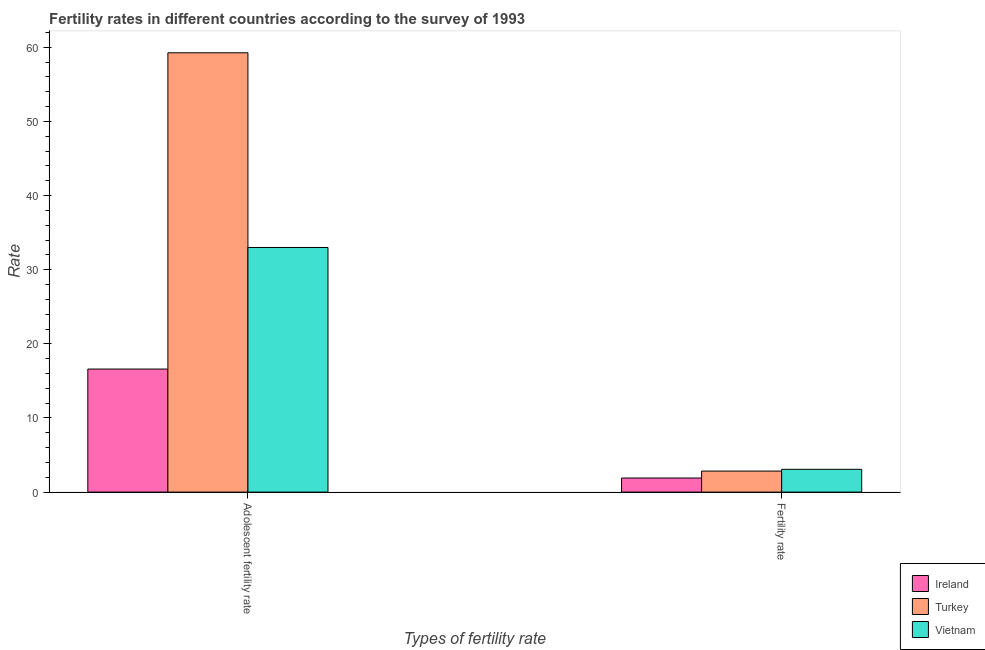Are the number of bars per tick equal to the number of legend labels?
Your answer should be compact. Yes. How many bars are there on the 2nd tick from the right?
Offer a terse response. 3. What is the label of the 2nd group of bars from the left?
Your answer should be very brief. Fertility rate. What is the adolescent fertility rate in Ireland?
Keep it short and to the point. 16.6. Across all countries, what is the maximum fertility rate?
Give a very brief answer. 3.07. Across all countries, what is the minimum adolescent fertility rate?
Keep it short and to the point. 16.6. In which country was the fertility rate maximum?
Offer a terse response. Vietnam. In which country was the adolescent fertility rate minimum?
Provide a succinct answer. Ireland. What is the total adolescent fertility rate in the graph?
Your response must be concise. 108.85. What is the difference between the adolescent fertility rate in Turkey and that in Vietnam?
Give a very brief answer. 26.26. What is the difference between the adolescent fertility rate in Ireland and the fertility rate in Turkey?
Give a very brief answer. 13.76. What is the average adolescent fertility rate per country?
Your answer should be very brief. 36.28. What is the difference between the fertility rate and adolescent fertility rate in Ireland?
Provide a succinct answer. -14.7. What is the ratio of the fertility rate in Turkey to that in Ireland?
Your answer should be very brief. 1.49. In how many countries, is the adolescent fertility rate greater than the average adolescent fertility rate taken over all countries?
Offer a terse response. 1. What does the 3rd bar from the left in Adolescent fertility rate represents?
Make the answer very short. Vietnam. What does the 3rd bar from the right in Fertility rate represents?
Your answer should be very brief. Ireland. How many bars are there?
Your response must be concise. 6. How many countries are there in the graph?
Make the answer very short. 3. What is the difference between two consecutive major ticks on the Y-axis?
Your answer should be very brief. 10. Does the graph contain any zero values?
Keep it short and to the point. No. Does the graph contain grids?
Your response must be concise. No. Where does the legend appear in the graph?
Keep it short and to the point. Bottom right. How are the legend labels stacked?
Ensure brevity in your answer.  Vertical. What is the title of the graph?
Make the answer very short. Fertility rates in different countries according to the survey of 1993. What is the label or title of the X-axis?
Keep it short and to the point. Types of fertility rate. What is the label or title of the Y-axis?
Make the answer very short. Rate. What is the Rate in Ireland in Adolescent fertility rate?
Your answer should be compact. 16.6. What is the Rate in Turkey in Adolescent fertility rate?
Provide a short and direct response. 59.26. What is the Rate of Vietnam in Adolescent fertility rate?
Offer a terse response. 33. What is the Rate of Ireland in Fertility rate?
Make the answer very short. 1.9. What is the Rate in Turkey in Fertility rate?
Ensure brevity in your answer.  2.83. What is the Rate in Vietnam in Fertility rate?
Make the answer very short. 3.07. Across all Types of fertility rate, what is the maximum Rate of Ireland?
Offer a very short reply. 16.6. Across all Types of fertility rate, what is the maximum Rate in Turkey?
Keep it short and to the point. 59.26. Across all Types of fertility rate, what is the maximum Rate of Vietnam?
Your answer should be very brief. 33. Across all Types of fertility rate, what is the minimum Rate in Ireland?
Provide a short and direct response. 1.9. Across all Types of fertility rate, what is the minimum Rate in Turkey?
Your answer should be very brief. 2.83. Across all Types of fertility rate, what is the minimum Rate of Vietnam?
Your answer should be compact. 3.07. What is the total Rate of Ireland in the graph?
Offer a terse response. 18.5. What is the total Rate in Turkey in the graph?
Keep it short and to the point. 62.09. What is the total Rate of Vietnam in the graph?
Ensure brevity in your answer.  36.07. What is the difference between the Rate of Ireland in Adolescent fertility rate and that in Fertility rate?
Offer a terse response. 14.7. What is the difference between the Rate in Turkey in Adolescent fertility rate and that in Fertility rate?
Provide a succinct answer. 56.42. What is the difference between the Rate in Vietnam in Adolescent fertility rate and that in Fertility rate?
Provide a succinct answer. 29.92. What is the difference between the Rate in Ireland in Adolescent fertility rate and the Rate in Turkey in Fertility rate?
Offer a very short reply. 13.76. What is the difference between the Rate of Ireland in Adolescent fertility rate and the Rate of Vietnam in Fertility rate?
Your response must be concise. 13.52. What is the difference between the Rate in Turkey in Adolescent fertility rate and the Rate in Vietnam in Fertility rate?
Provide a succinct answer. 56.18. What is the average Rate in Ireland per Types of fertility rate?
Offer a terse response. 9.25. What is the average Rate in Turkey per Types of fertility rate?
Ensure brevity in your answer.  31.05. What is the average Rate in Vietnam per Types of fertility rate?
Provide a short and direct response. 18.04. What is the difference between the Rate in Ireland and Rate in Turkey in Adolescent fertility rate?
Your response must be concise. -42.66. What is the difference between the Rate of Ireland and Rate of Vietnam in Adolescent fertility rate?
Offer a very short reply. -16.4. What is the difference between the Rate of Turkey and Rate of Vietnam in Adolescent fertility rate?
Provide a short and direct response. 26.26. What is the difference between the Rate in Ireland and Rate in Turkey in Fertility rate?
Provide a short and direct response. -0.94. What is the difference between the Rate of Ireland and Rate of Vietnam in Fertility rate?
Provide a short and direct response. -1.17. What is the difference between the Rate of Turkey and Rate of Vietnam in Fertility rate?
Provide a succinct answer. -0.24. What is the ratio of the Rate of Ireland in Adolescent fertility rate to that in Fertility rate?
Provide a succinct answer. 8.74. What is the ratio of the Rate of Turkey in Adolescent fertility rate to that in Fertility rate?
Your response must be concise. 20.9. What is the ratio of the Rate of Vietnam in Adolescent fertility rate to that in Fertility rate?
Ensure brevity in your answer.  10.73. What is the difference between the highest and the second highest Rate in Ireland?
Your answer should be compact. 14.7. What is the difference between the highest and the second highest Rate of Turkey?
Your response must be concise. 56.42. What is the difference between the highest and the second highest Rate of Vietnam?
Your answer should be very brief. 29.92. What is the difference between the highest and the lowest Rate of Ireland?
Provide a succinct answer. 14.7. What is the difference between the highest and the lowest Rate of Turkey?
Provide a succinct answer. 56.42. What is the difference between the highest and the lowest Rate in Vietnam?
Ensure brevity in your answer.  29.92. 